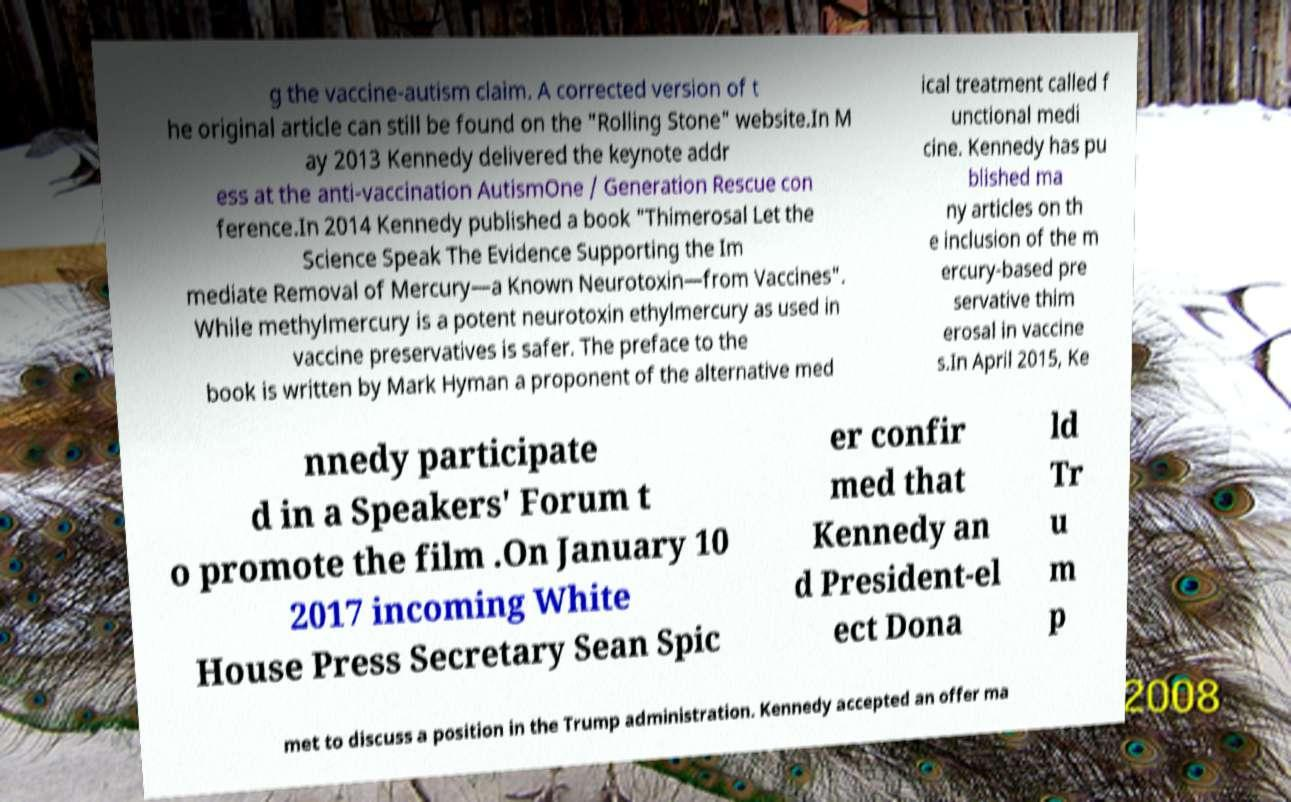Please identify and transcribe the text found in this image. g the vaccine-autism claim. A corrected version of t he original article can still be found on the "Rolling Stone" website.In M ay 2013 Kennedy delivered the keynote addr ess at the anti-vaccination AutismOne / Generation Rescue con ference.In 2014 Kennedy published a book "Thimerosal Let the Science Speak The Evidence Supporting the Im mediate Removal of Mercury—a Known Neurotoxin—from Vaccines". While methylmercury is a potent neurotoxin ethylmercury as used in vaccine preservatives is safer. The preface to the book is written by Mark Hyman a proponent of the alternative med ical treatment called f unctional medi cine. Kennedy has pu blished ma ny articles on th e inclusion of the m ercury-based pre servative thim erosal in vaccine s.In April 2015, Ke nnedy participate d in a Speakers' Forum t o promote the film .On January 10 2017 incoming White House Press Secretary Sean Spic er confir med that Kennedy an d President-el ect Dona ld Tr u m p met to discuss a position in the Trump administration. Kennedy accepted an offer ma 